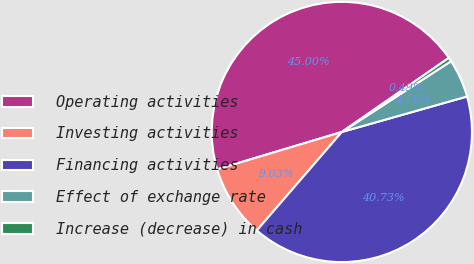Convert chart. <chart><loc_0><loc_0><loc_500><loc_500><pie_chart><fcel>Operating activities<fcel>Investing activities<fcel>Financing activities<fcel>Effect of exchange rate<fcel>Increase (decrease) in cash<nl><fcel>45.0%<fcel>9.03%<fcel>40.73%<fcel>4.76%<fcel>0.49%<nl></chart> 